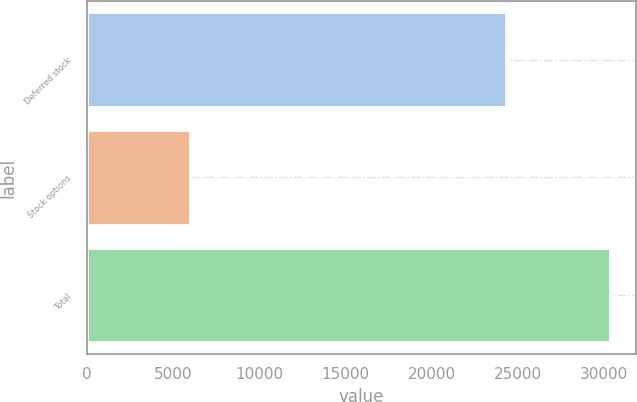Convert chart to OTSL. <chart><loc_0><loc_0><loc_500><loc_500><bar_chart><fcel>Deferred stock<fcel>Stock options<fcel>Total<nl><fcel>24318<fcel>6020<fcel>30338<nl></chart> 